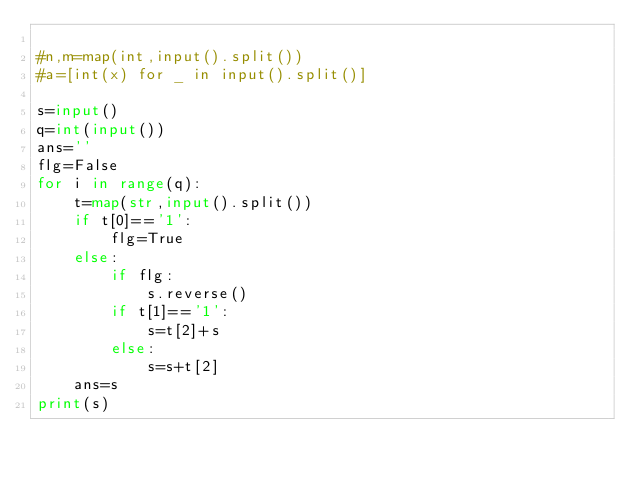<code> <loc_0><loc_0><loc_500><loc_500><_Python_>
#n,m=map(int,input().split())
#a=[int(x) for _ in input().split()]

s=input()
q=int(input())
ans=''
flg=False
for i in range(q):
    t=map(str,input().split())
    if t[0]=='1':
    	flg=True
    else:
		if flg:
			s.reverse()
        if t[1]=='1':
			s=t[2]+s
        else:
            s=s+t[2]
    ans=s
print(s)</code> 